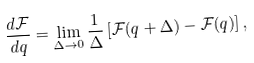<formula> <loc_0><loc_0><loc_500><loc_500>\frac { d \mathcal { F } } { d q } = \lim _ { \Delta \to 0 } \frac { 1 } { \Delta } \left [ \mathcal { F } ( q + \Delta ) - \mathcal { F } ( q ) \right ] ,</formula> 